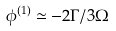Convert formula to latex. <formula><loc_0><loc_0><loc_500><loc_500>\phi ^ { ( 1 ) } \simeq - 2 \Gamma / 3 \Omega</formula> 